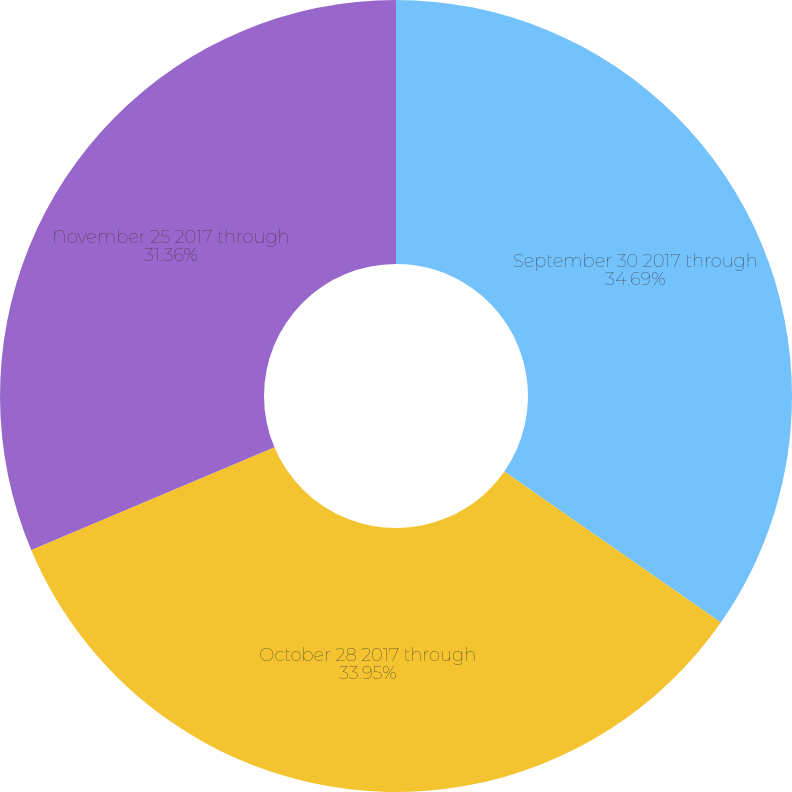<chart> <loc_0><loc_0><loc_500><loc_500><pie_chart><fcel>September 30 2017 through<fcel>October 28 2017 through<fcel>November 25 2017 through<nl><fcel>34.69%<fcel>33.95%<fcel>31.36%<nl></chart> 